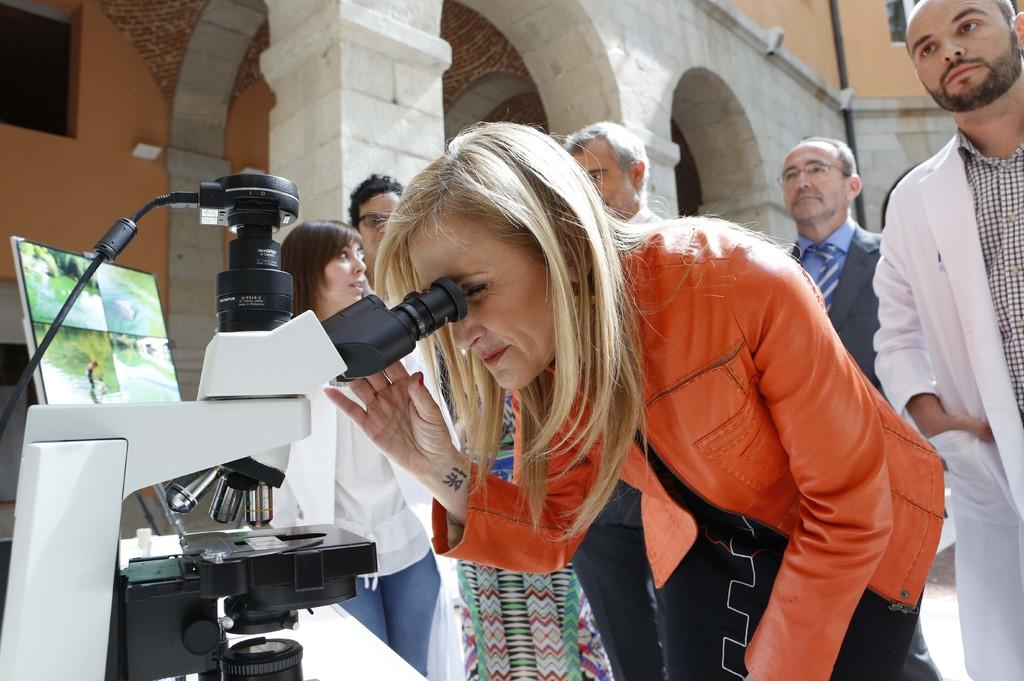Who or what can be seen in the image? There are people in the image. What equipment is visible in the image? There is a microscope in the image. What device is present for displaying information? There is a screen in the image. What architectural features can be seen in the background of the image? There are arches, pillars, and a wall in the background of the image. What vertical structure is present in the background of the image? There is a pole in the background of the image. How many ladybugs can be seen crawling on the pole in the image? There are no ladybugs present in the image; the pole is in the background and no insects are visible. 